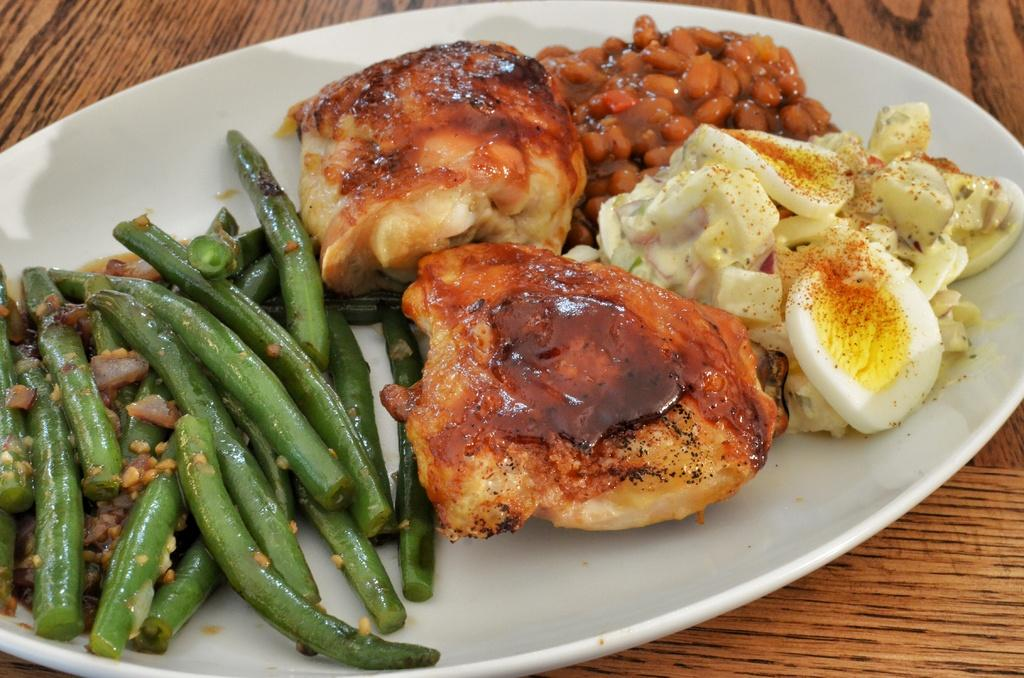What piece of furniture is present in the image? There is a table in the image. What is placed on the table? There is a plate on the table. What is on the plate? There is food on the plate. What type of bottle is visible on the plate in the image? There is no bottle present on the plate or in the image. 